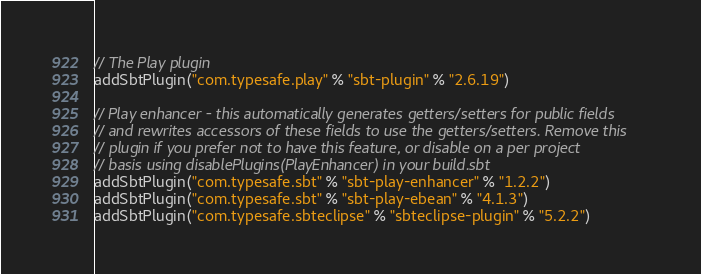<code> <loc_0><loc_0><loc_500><loc_500><_Scala_>// The Play plugin
addSbtPlugin("com.typesafe.play" % "sbt-plugin" % "2.6.19")

// Play enhancer - this automatically generates getters/setters for public fields
// and rewrites accessors of these fields to use the getters/setters. Remove this
// plugin if you prefer not to have this feature, or disable on a per project
// basis using disablePlugins(PlayEnhancer) in your build.sbt
addSbtPlugin("com.typesafe.sbt" % "sbt-play-enhancer" % "1.2.2")
addSbtPlugin("com.typesafe.sbt" % "sbt-play-ebean" % "4.1.3")
addSbtPlugin("com.typesafe.sbteclipse" % "sbteclipse-plugin" % "5.2.2")

</code> 